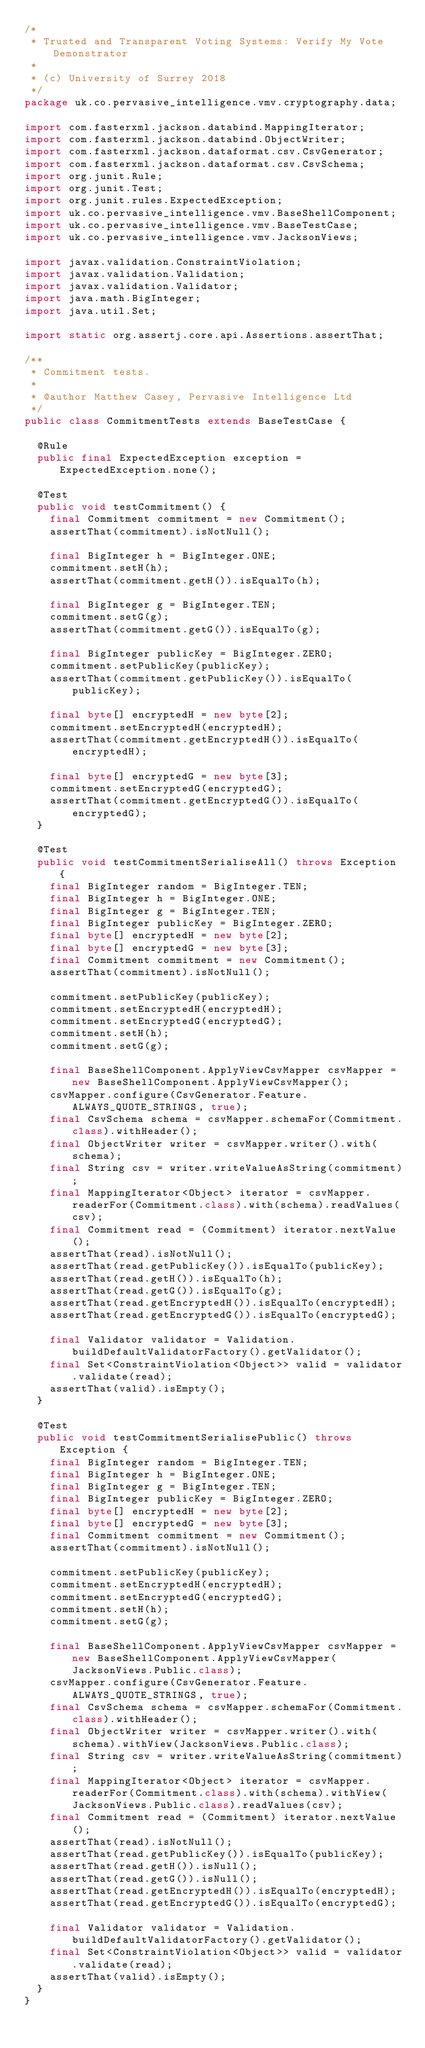<code> <loc_0><loc_0><loc_500><loc_500><_Java_>/*
 * Trusted and Transparent Voting Systems: Verify My Vote Demonstrator
 *
 * (c) University of Surrey 2018
 */
package uk.co.pervasive_intelligence.vmv.cryptography.data;

import com.fasterxml.jackson.databind.MappingIterator;
import com.fasterxml.jackson.databind.ObjectWriter;
import com.fasterxml.jackson.dataformat.csv.CsvGenerator;
import com.fasterxml.jackson.dataformat.csv.CsvSchema;
import org.junit.Rule;
import org.junit.Test;
import org.junit.rules.ExpectedException;
import uk.co.pervasive_intelligence.vmv.BaseShellComponent;
import uk.co.pervasive_intelligence.vmv.BaseTestCase;
import uk.co.pervasive_intelligence.vmv.JacksonViews;

import javax.validation.ConstraintViolation;
import javax.validation.Validation;
import javax.validation.Validator;
import java.math.BigInteger;
import java.util.Set;

import static org.assertj.core.api.Assertions.assertThat;

/**
 * Commitment tests.
 *
 * @author Matthew Casey, Pervasive Intelligence Ltd
 */
public class CommitmentTests extends BaseTestCase {

  @Rule
  public final ExpectedException exception = ExpectedException.none();

  @Test
  public void testCommitment() {
    final Commitment commitment = new Commitment();
    assertThat(commitment).isNotNull();

    final BigInteger h = BigInteger.ONE;
    commitment.setH(h);
    assertThat(commitment.getH()).isEqualTo(h);

    final BigInteger g = BigInteger.TEN;
    commitment.setG(g);
    assertThat(commitment.getG()).isEqualTo(g);

    final BigInteger publicKey = BigInteger.ZERO;
    commitment.setPublicKey(publicKey);
    assertThat(commitment.getPublicKey()).isEqualTo(publicKey);

    final byte[] encryptedH = new byte[2];
    commitment.setEncryptedH(encryptedH);
    assertThat(commitment.getEncryptedH()).isEqualTo(encryptedH);

    final byte[] encryptedG = new byte[3];
    commitment.setEncryptedG(encryptedG);
    assertThat(commitment.getEncryptedG()).isEqualTo(encryptedG);
  }

  @Test
  public void testCommitmentSerialiseAll() throws Exception {
    final BigInteger random = BigInteger.TEN;
    final BigInteger h = BigInteger.ONE;
    final BigInteger g = BigInteger.TEN;
    final BigInteger publicKey = BigInteger.ZERO;
    final byte[] encryptedH = new byte[2];
    final byte[] encryptedG = new byte[3];
    final Commitment commitment = new Commitment();
    assertThat(commitment).isNotNull();

    commitment.setPublicKey(publicKey);
    commitment.setEncryptedH(encryptedH);
    commitment.setEncryptedG(encryptedG);
    commitment.setH(h);
    commitment.setG(g);

    final BaseShellComponent.ApplyViewCsvMapper csvMapper = new BaseShellComponent.ApplyViewCsvMapper();
    csvMapper.configure(CsvGenerator.Feature.ALWAYS_QUOTE_STRINGS, true);
    final CsvSchema schema = csvMapper.schemaFor(Commitment.class).withHeader();
    final ObjectWriter writer = csvMapper.writer().with(schema);
    final String csv = writer.writeValueAsString(commitment);
    final MappingIterator<Object> iterator = csvMapper.readerFor(Commitment.class).with(schema).readValues(csv);
    final Commitment read = (Commitment) iterator.nextValue();
    assertThat(read).isNotNull();
    assertThat(read.getPublicKey()).isEqualTo(publicKey);
    assertThat(read.getH()).isEqualTo(h);
    assertThat(read.getG()).isEqualTo(g);
    assertThat(read.getEncryptedH()).isEqualTo(encryptedH);
    assertThat(read.getEncryptedG()).isEqualTo(encryptedG);

    final Validator validator = Validation.buildDefaultValidatorFactory().getValidator();
    final Set<ConstraintViolation<Object>> valid = validator.validate(read);
    assertThat(valid).isEmpty();
  }

  @Test
  public void testCommitmentSerialisePublic() throws Exception {
    final BigInteger random = BigInteger.TEN;
    final BigInteger h = BigInteger.ONE;
    final BigInteger g = BigInteger.TEN;
    final BigInteger publicKey = BigInteger.ZERO;
    final byte[] encryptedH = new byte[2];
    final byte[] encryptedG = new byte[3];
    final Commitment commitment = new Commitment();
    assertThat(commitment).isNotNull();

    commitment.setPublicKey(publicKey);
    commitment.setEncryptedH(encryptedH);
    commitment.setEncryptedG(encryptedG);
    commitment.setH(h);
    commitment.setG(g);

    final BaseShellComponent.ApplyViewCsvMapper csvMapper = new BaseShellComponent.ApplyViewCsvMapper(JacksonViews.Public.class);
    csvMapper.configure(CsvGenerator.Feature.ALWAYS_QUOTE_STRINGS, true);
    final CsvSchema schema = csvMapper.schemaFor(Commitment.class).withHeader();
    final ObjectWriter writer = csvMapper.writer().with(schema).withView(JacksonViews.Public.class);
    final String csv = writer.writeValueAsString(commitment);
    final MappingIterator<Object> iterator = csvMapper.readerFor(Commitment.class).with(schema).withView(JacksonViews.Public.class).readValues(csv);
    final Commitment read = (Commitment) iterator.nextValue();
    assertThat(read).isNotNull();
    assertThat(read.getPublicKey()).isEqualTo(publicKey);
    assertThat(read.getH()).isNull();
    assertThat(read.getG()).isNull();
    assertThat(read.getEncryptedH()).isEqualTo(encryptedH);
    assertThat(read.getEncryptedG()).isEqualTo(encryptedG);

    final Validator validator = Validation.buildDefaultValidatorFactory().getValidator();
    final Set<ConstraintViolation<Object>> valid = validator.validate(read);
    assertThat(valid).isEmpty();
  }
}
</code> 